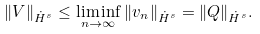Convert formula to latex. <formula><loc_0><loc_0><loc_500><loc_500>\| V \| _ { \dot { H } ^ { s } } \leq \liminf _ { n \rightarrow \infty } \| v _ { n } \| _ { \dot { H } ^ { s } } = \| Q \| _ { \dot { H } ^ { s } } .</formula> 